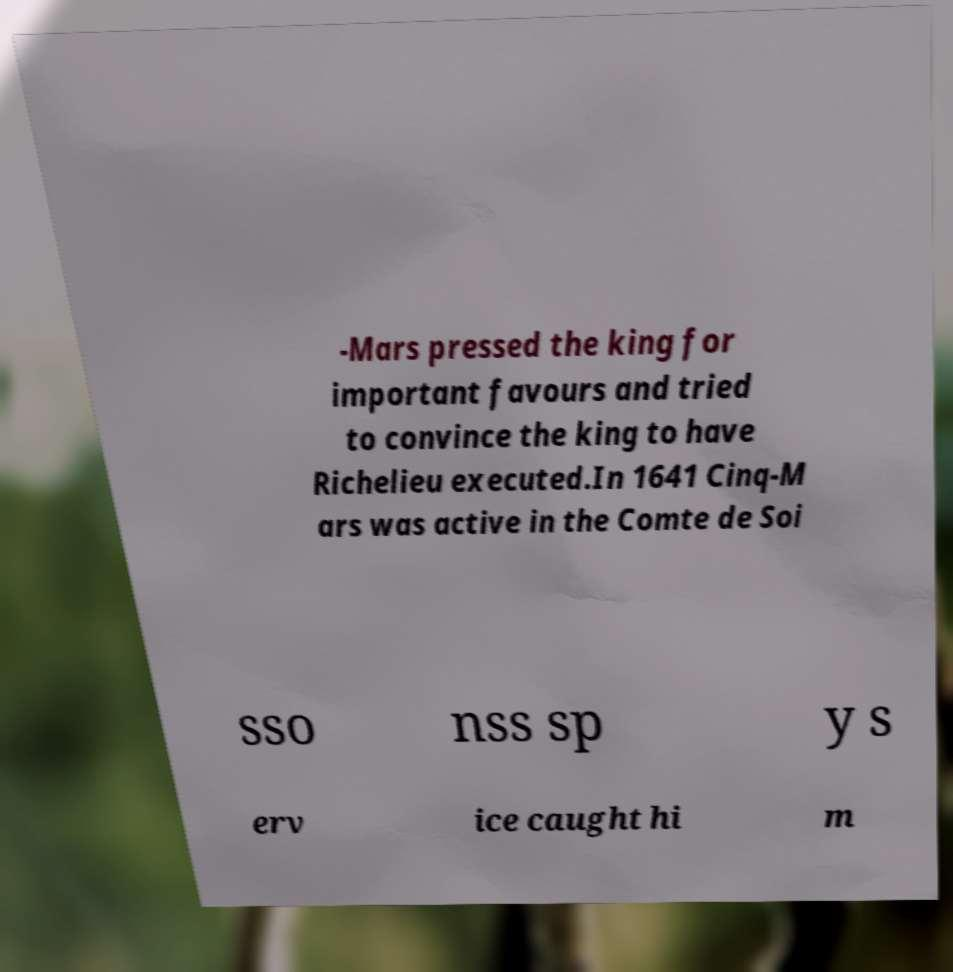Can you accurately transcribe the text from the provided image for me? -Mars pressed the king for important favours and tried to convince the king to have Richelieu executed.In 1641 Cinq-M ars was active in the Comte de Soi sso nss sp y s erv ice caught hi m 